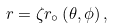<formula> <loc_0><loc_0><loc_500><loc_500>r = \zeta r _ { \circ } \left ( \theta , \phi \right ) ,</formula> 